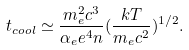Convert formula to latex. <formula><loc_0><loc_0><loc_500><loc_500>t _ { c o o l } \simeq \frac { m _ { e } ^ { 2 } c ^ { 3 } } { \alpha _ { e } e ^ { 4 } n } ( \frac { k T } { m _ { e } c ^ { 2 } } ) ^ { 1 / 2 } .</formula> 